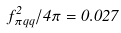Convert formula to latex. <formula><loc_0><loc_0><loc_500><loc_500>f _ { \pi q q } ^ { 2 } / 4 \pi = 0 . 0 2 7</formula> 